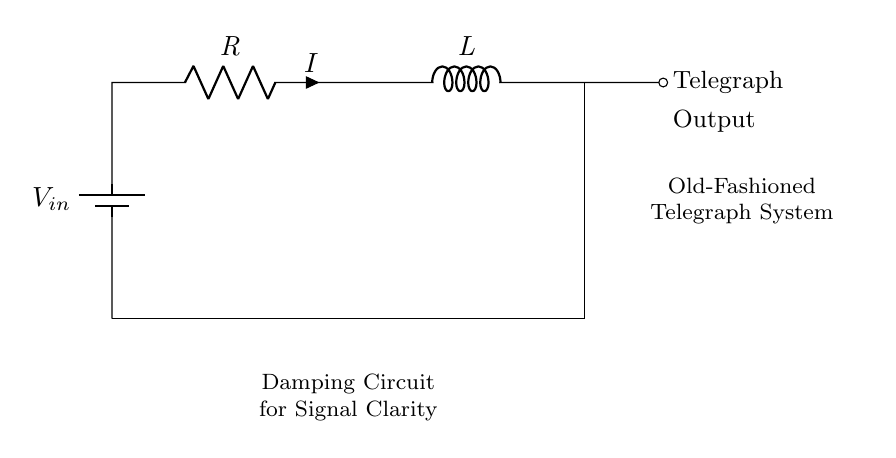What is the input voltage of this circuit? The input voltage is denoted as Vin, which is the source of electrical energy in the circuit.
Answer: Vin What type of circuit is represented here? The circuit includes a resistor and an inductor connected in series, forming a resistor-inductor (RL) circuit.
Answer: Resistor-Inductor What is the function of the resistor in this circuit? The resistor limits the current flow through the circuit, helping to dampen the oscillations caused by the inductor and stabilize the signal.
Answer: Damping How does the inductor affect the circuit behavior? The inductor stores energy in its magnetic field when current flows, which can lead to delayed current changes and contribute to the damping effect alongside the resistor.
Answer: Delayed current changes What is the primary purpose of this damping circuit in telegraph systems? The damping circuit serves to enhance signal clarity by reducing oscillations and noise that can interfere with the transmission of messages.
Answer: Signal clarity What does the output indicate in this diagram? The output indicates where the telegraphic signal is transmitted from the damping circuit, which will carry the processed signal to the telegraph system.
Answer: Telegraph Output 